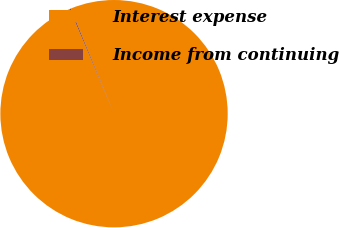<chart> <loc_0><loc_0><loc_500><loc_500><pie_chart><fcel>Interest expense<fcel>Income from continuing<nl><fcel>99.84%<fcel>0.16%<nl></chart> 